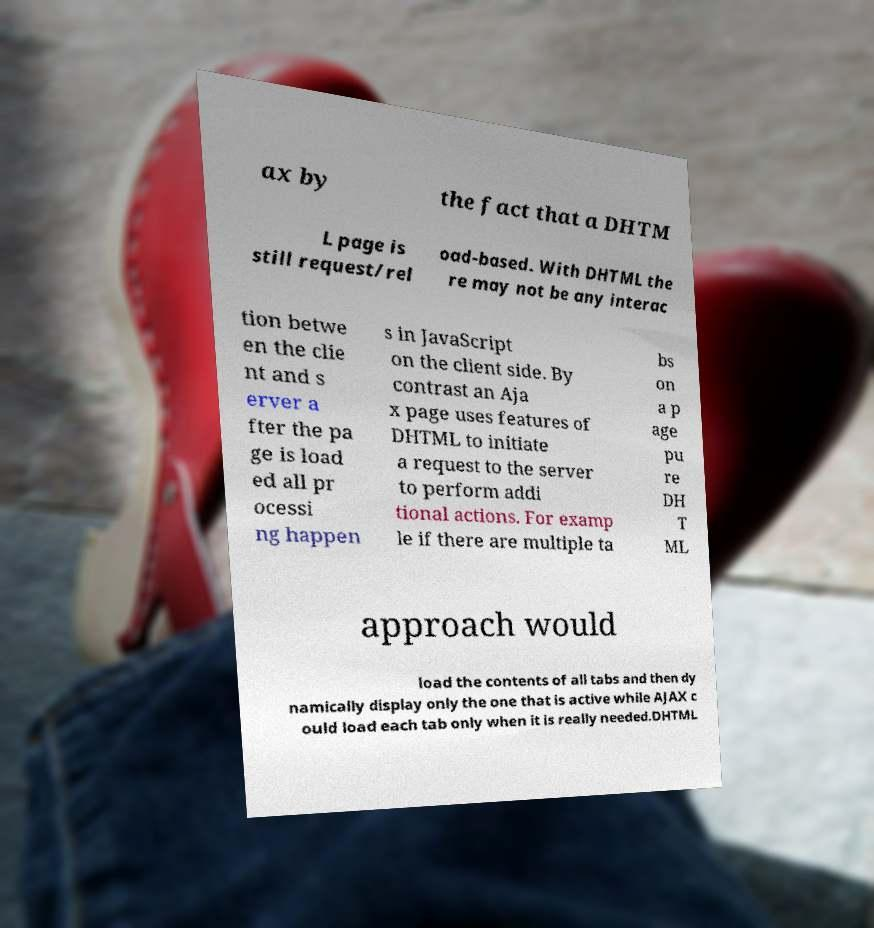Please read and relay the text visible in this image. What does it say? ax by the fact that a DHTM L page is still request/rel oad-based. With DHTML the re may not be any interac tion betwe en the clie nt and s erver a fter the pa ge is load ed all pr ocessi ng happen s in JavaScript on the client side. By contrast an Aja x page uses features of DHTML to initiate a request to the server to perform addi tional actions. For examp le if there are multiple ta bs on a p age pu re DH T ML approach would load the contents of all tabs and then dy namically display only the one that is active while AJAX c ould load each tab only when it is really needed.DHTML 